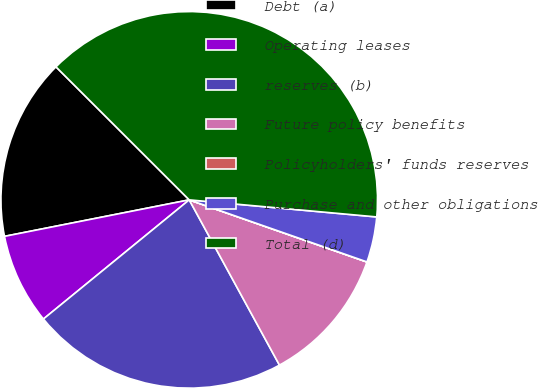Convert chart to OTSL. <chart><loc_0><loc_0><loc_500><loc_500><pie_chart><fcel>Debt (a)<fcel>Operating leases<fcel>reserves (b)<fcel>Future policy benefits<fcel>Policyholders' funds reserves<fcel>Purchase and other obligations<fcel>Total (d)<nl><fcel>15.59%<fcel>7.8%<fcel>22.05%<fcel>11.69%<fcel>0.01%<fcel>3.9%<fcel>38.96%<nl></chart> 